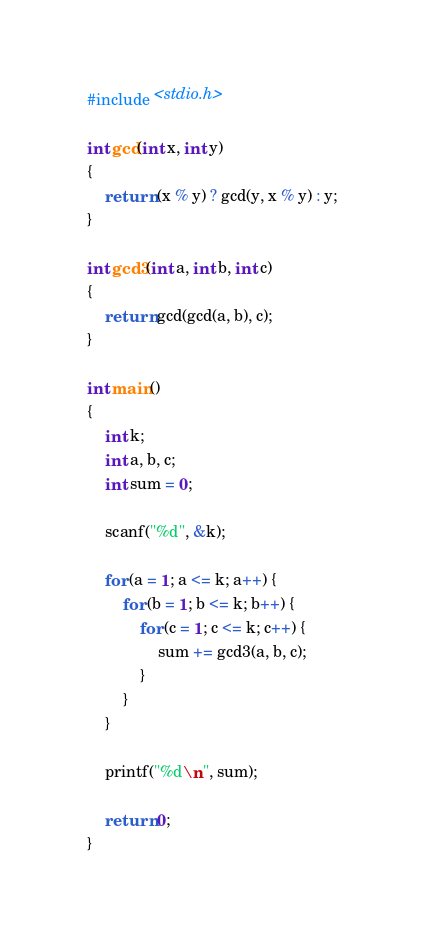Convert code to text. <code><loc_0><loc_0><loc_500><loc_500><_C_>#include <stdio.h>

int gcd(int x, int y)
{
    return (x % y) ? gcd(y, x % y) : y;
}

int gcd3(int a, int b, int c)
{
    return gcd(gcd(a, b), c);
}

int main()
{
    int k;
    int a, b, c;
    int sum = 0;

    scanf("%d", &k);

    for (a = 1; a <= k; a++) {
        for (b = 1; b <= k; b++) {
            for (c = 1; c <= k; c++) {
                sum += gcd3(a, b, c);
            }
        }
    }

    printf("%d\n", sum);

    return 0;
}</code> 